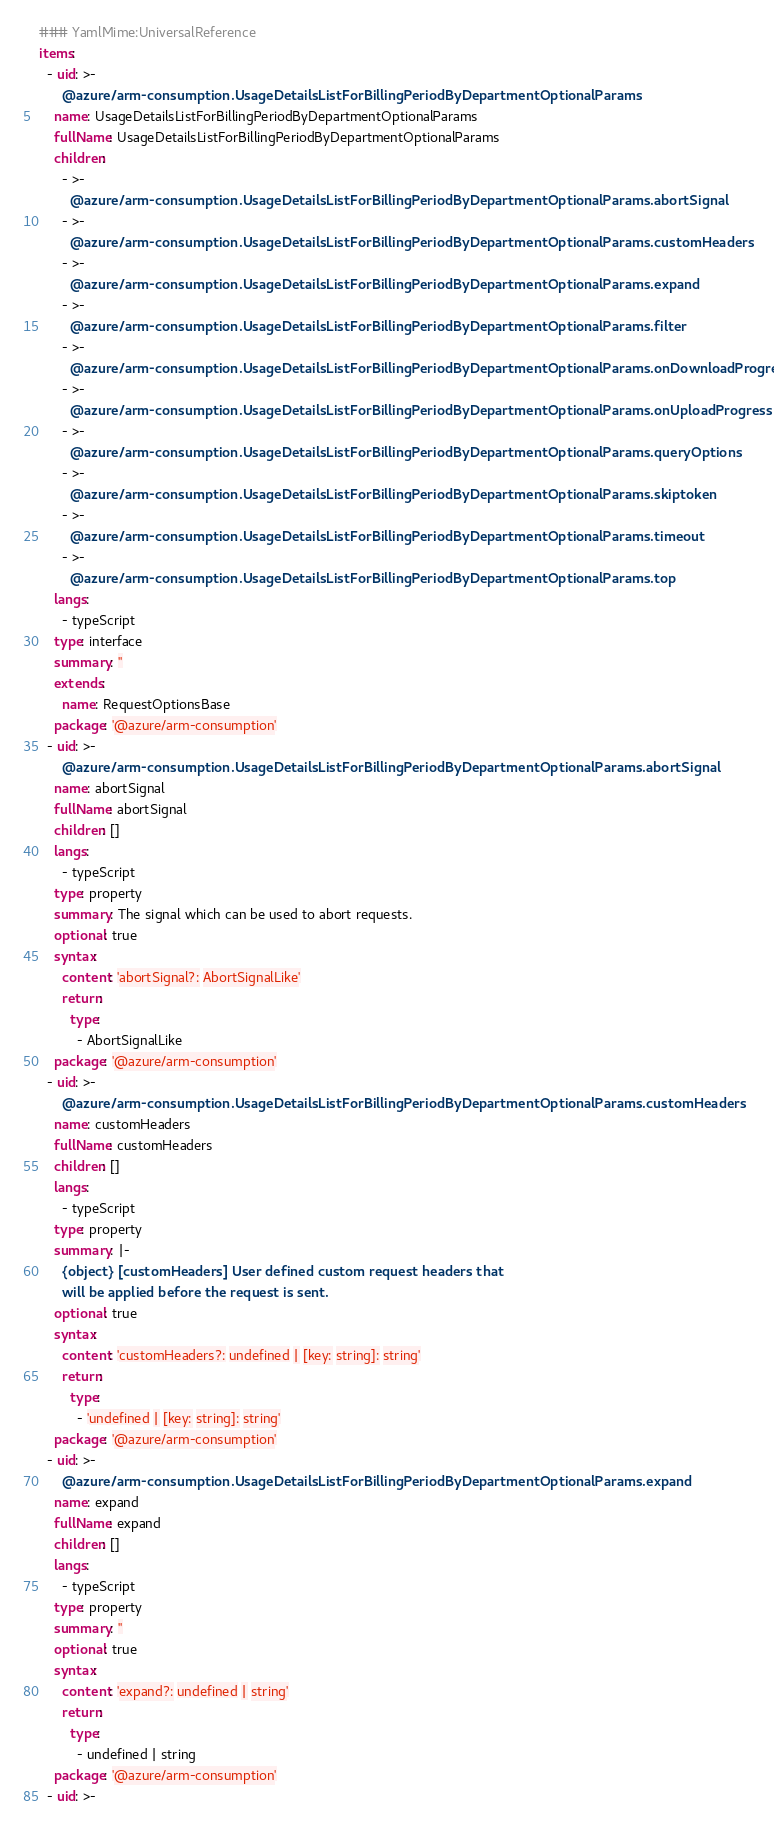Convert code to text. <code><loc_0><loc_0><loc_500><loc_500><_YAML_>### YamlMime:UniversalReference
items:
  - uid: >-
      @azure/arm-consumption.UsageDetailsListForBillingPeriodByDepartmentOptionalParams
    name: UsageDetailsListForBillingPeriodByDepartmentOptionalParams
    fullName: UsageDetailsListForBillingPeriodByDepartmentOptionalParams
    children:
      - >-
        @azure/arm-consumption.UsageDetailsListForBillingPeriodByDepartmentOptionalParams.abortSignal
      - >-
        @azure/arm-consumption.UsageDetailsListForBillingPeriodByDepartmentOptionalParams.customHeaders
      - >-
        @azure/arm-consumption.UsageDetailsListForBillingPeriodByDepartmentOptionalParams.expand
      - >-
        @azure/arm-consumption.UsageDetailsListForBillingPeriodByDepartmentOptionalParams.filter
      - >-
        @azure/arm-consumption.UsageDetailsListForBillingPeriodByDepartmentOptionalParams.onDownloadProgress
      - >-
        @azure/arm-consumption.UsageDetailsListForBillingPeriodByDepartmentOptionalParams.onUploadProgress
      - >-
        @azure/arm-consumption.UsageDetailsListForBillingPeriodByDepartmentOptionalParams.queryOptions
      - >-
        @azure/arm-consumption.UsageDetailsListForBillingPeriodByDepartmentOptionalParams.skiptoken
      - >-
        @azure/arm-consumption.UsageDetailsListForBillingPeriodByDepartmentOptionalParams.timeout
      - >-
        @azure/arm-consumption.UsageDetailsListForBillingPeriodByDepartmentOptionalParams.top
    langs:
      - typeScript
    type: interface
    summary: ''
    extends:
      name: RequestOptionsBase
    package: '@azure/arm-consumption'
  - uid: >-
      @azure/arm-consumption.UsageDetailsListForBillingPeriodByDepartmentOptionalParams.abortSignal
    name: abortSignal
    fullName: abortSignal
    children: []
    langs:
      - typeScript
    type: property
    summary: The signal which can be used to abort requests.
    optional: true
    syntax:
      content: 'abortSignal?: AbortSignalLike'
      return:
        type:
          - AbortSignalLike
    package: '@azure/arm-consumption'
  - uid: >-
      @azure/arm-consumption.UsageDetailsListForBillingPeriodByDepartmentOptionalParams.customHeaders
    name: customHeaders
    fullName: customHeaders
    children: []
    langs:
      - typeScript
    type: property
    summary: |-
      {object} [customHeaders] User defined custom request headers that
      will be applied before the request is sent.
    optional: true
    syntax:
      content: 'customHeaders?: undefined | [key: string]: string'
      return:
        type:
          - 'undefined | [key: string]: string'
    package: '@azure/arm-consumption'
  - uid: >-
      @azure/arm-consumption.UsageDetailsListForBillingPeriodByDepartmentOptionalParams.expand
    name: expand
    fullName: expand
    children: []
    langs:
      - typeScript
    type: property
    summary: ''
    optional: true
    syntax:
      content: 'expand?: undefined | string'
      return:
        type:
          - undefined | string
    package: '@azure/arm-consumption'
  - uid: >-</code> 